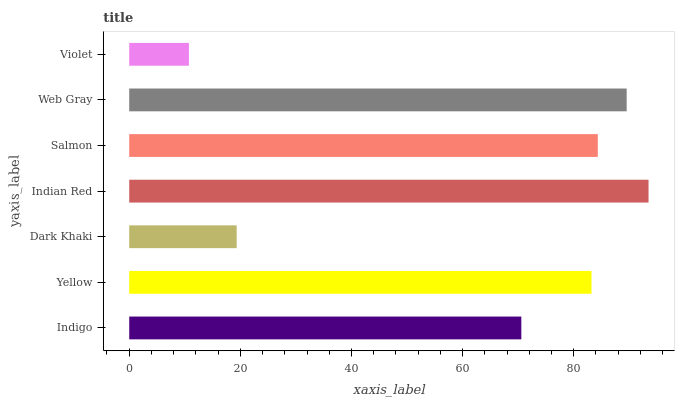Is Violet the minimum?
Answer yes or no. Yes. Is Indian Red the maximum?
Answer yes or no. Yes. Is Yellow the minimum?
Answer yes or no. No. Is Yellow the maximum?
Answer yes or no. No. Is Yellow greater than Indigo?
Answer yes or no. Yes. Is Indigo less than Yellow?
Answer yes or no. Yes. Is Indigo greater than Yellow?
Answer yes or no. No. Is Yellow less than Indigo?
Answer yes or no. No. Is Yellow the high median?
Answer yes or no. Yes. Is Yellow the low median?
Answer yes or no. Yes. Is Salmon the high median?
Answer yes or no. No. Is Violet the low median?
Answer yes or no. No. 